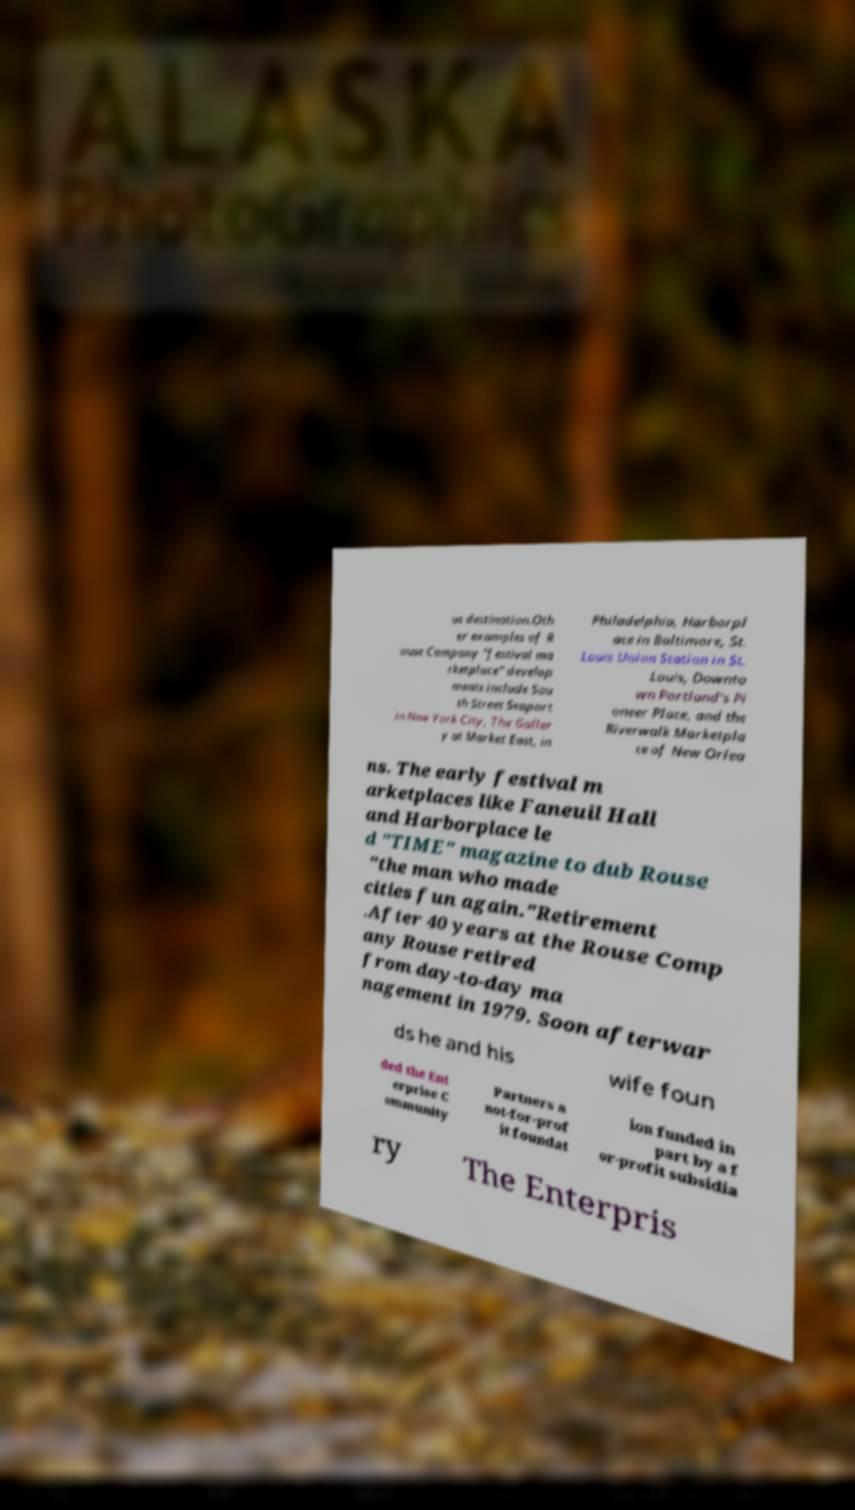Could you extract and type out the text from this image? us destination.Oth er examples of R ouse Company "festival ma rketplace" develop ments include Sou th Street Seaport in New York City, The Galler y at Market East, in Philadelphia, Harborpl ace in Baltimore, St. Louis Union Station in St. Louis, Downto wn Portland's Pi oneer Place, and the Riverwalk Marketpla ce of New Orlea ns. The early festival m arketplaces like Faneuil Hall and Harborplace le d "TIME" magazine to dub Rouse "the man who made cities fun again."Retirement .After 40 years at the Rouse Comp any Rouse retired from day-to-day ma nagement in 1979. Soon afterwar ds he and his wife foun ded the Ent erprise C ommunity Partners a not-for-prof it foundat ion funded in part by a f or-profit subsidia ry The Enterpris 